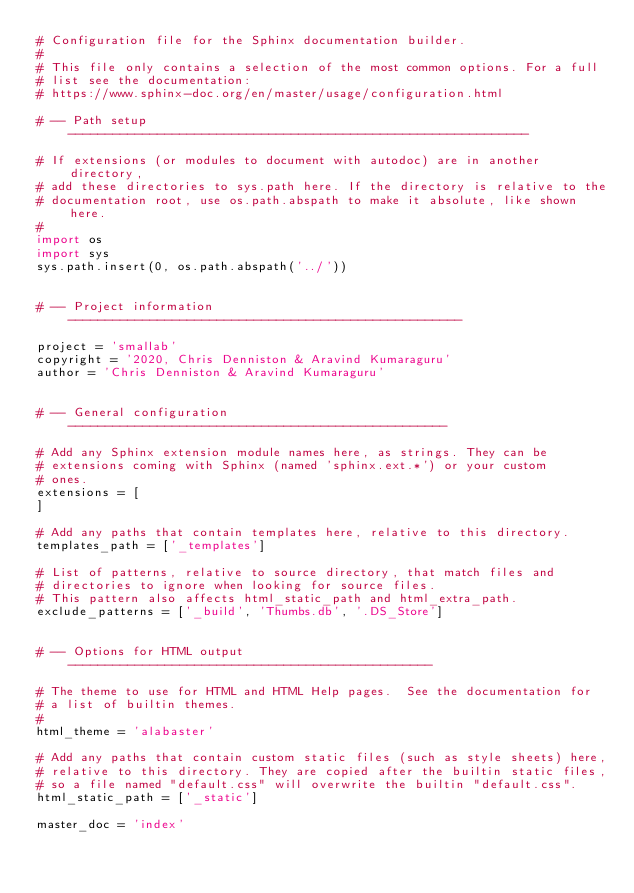Convert code to text. <code><loc_0><loc_0><loc_500><loc_500><_Python_># Configuration file for the Sphinx documentation builder.
#
# This file only contains a selection of the most common options. For a full
# list see the documentation:
# https://www.sphinx-doc.org/en/master/usage/configuration.html

# -- Path setup --------------------------------------------------------------

# If extensions (or modules to document with autodoc) are in another directory,
# add these directories to sys.path here. If the directory is relative to the
# documentation root, use os.path.abspath to make it absolute, like shown here.
#
import os
import sys
sys.path.insert(0, os.path.abspath('../'))


# -- Project information -----------------------------------------------------

project = 'smallab'
copyright = '2020, Chris Denniston & Aravind Kumaraguru'
author = 'Chris Denniston & Aravind Kumaraguru'


# -- General configuration ---------------------------------------------------

# Add any Sphinx extension module names here, as strings. They can be
# extensions coming with Sphinx (named 'sphinx.ext.*') or your custom
# ones.
extensions = [
]

# Add any paths that contain templates here, relative to this directory.
templates_path = ['_templates']

# List of patterns, relative to source directory, that match files and
# directories to ignore when looking for source files.
# This pattern also affects html_static_path and html_extra_path.
exclude_patterns = ['_build', 'Thumbs.db', '.DS_Store']


# -- Options for HTML output -------------------------------------------------

# The theme to use for HTML and HTML Help pages.  See the documentation for
# a list of builtin themes.
#
html_theme = 'alabaster'

# Add any paths that contain custom static files (such as style sheets) here,
# relative to this directory. They are copied after the builtin static files,
# so a file named "default.css" will overwrite the builtin "default.css".
html_static_path = ['_static']

master_doc = 'index'
</code> 